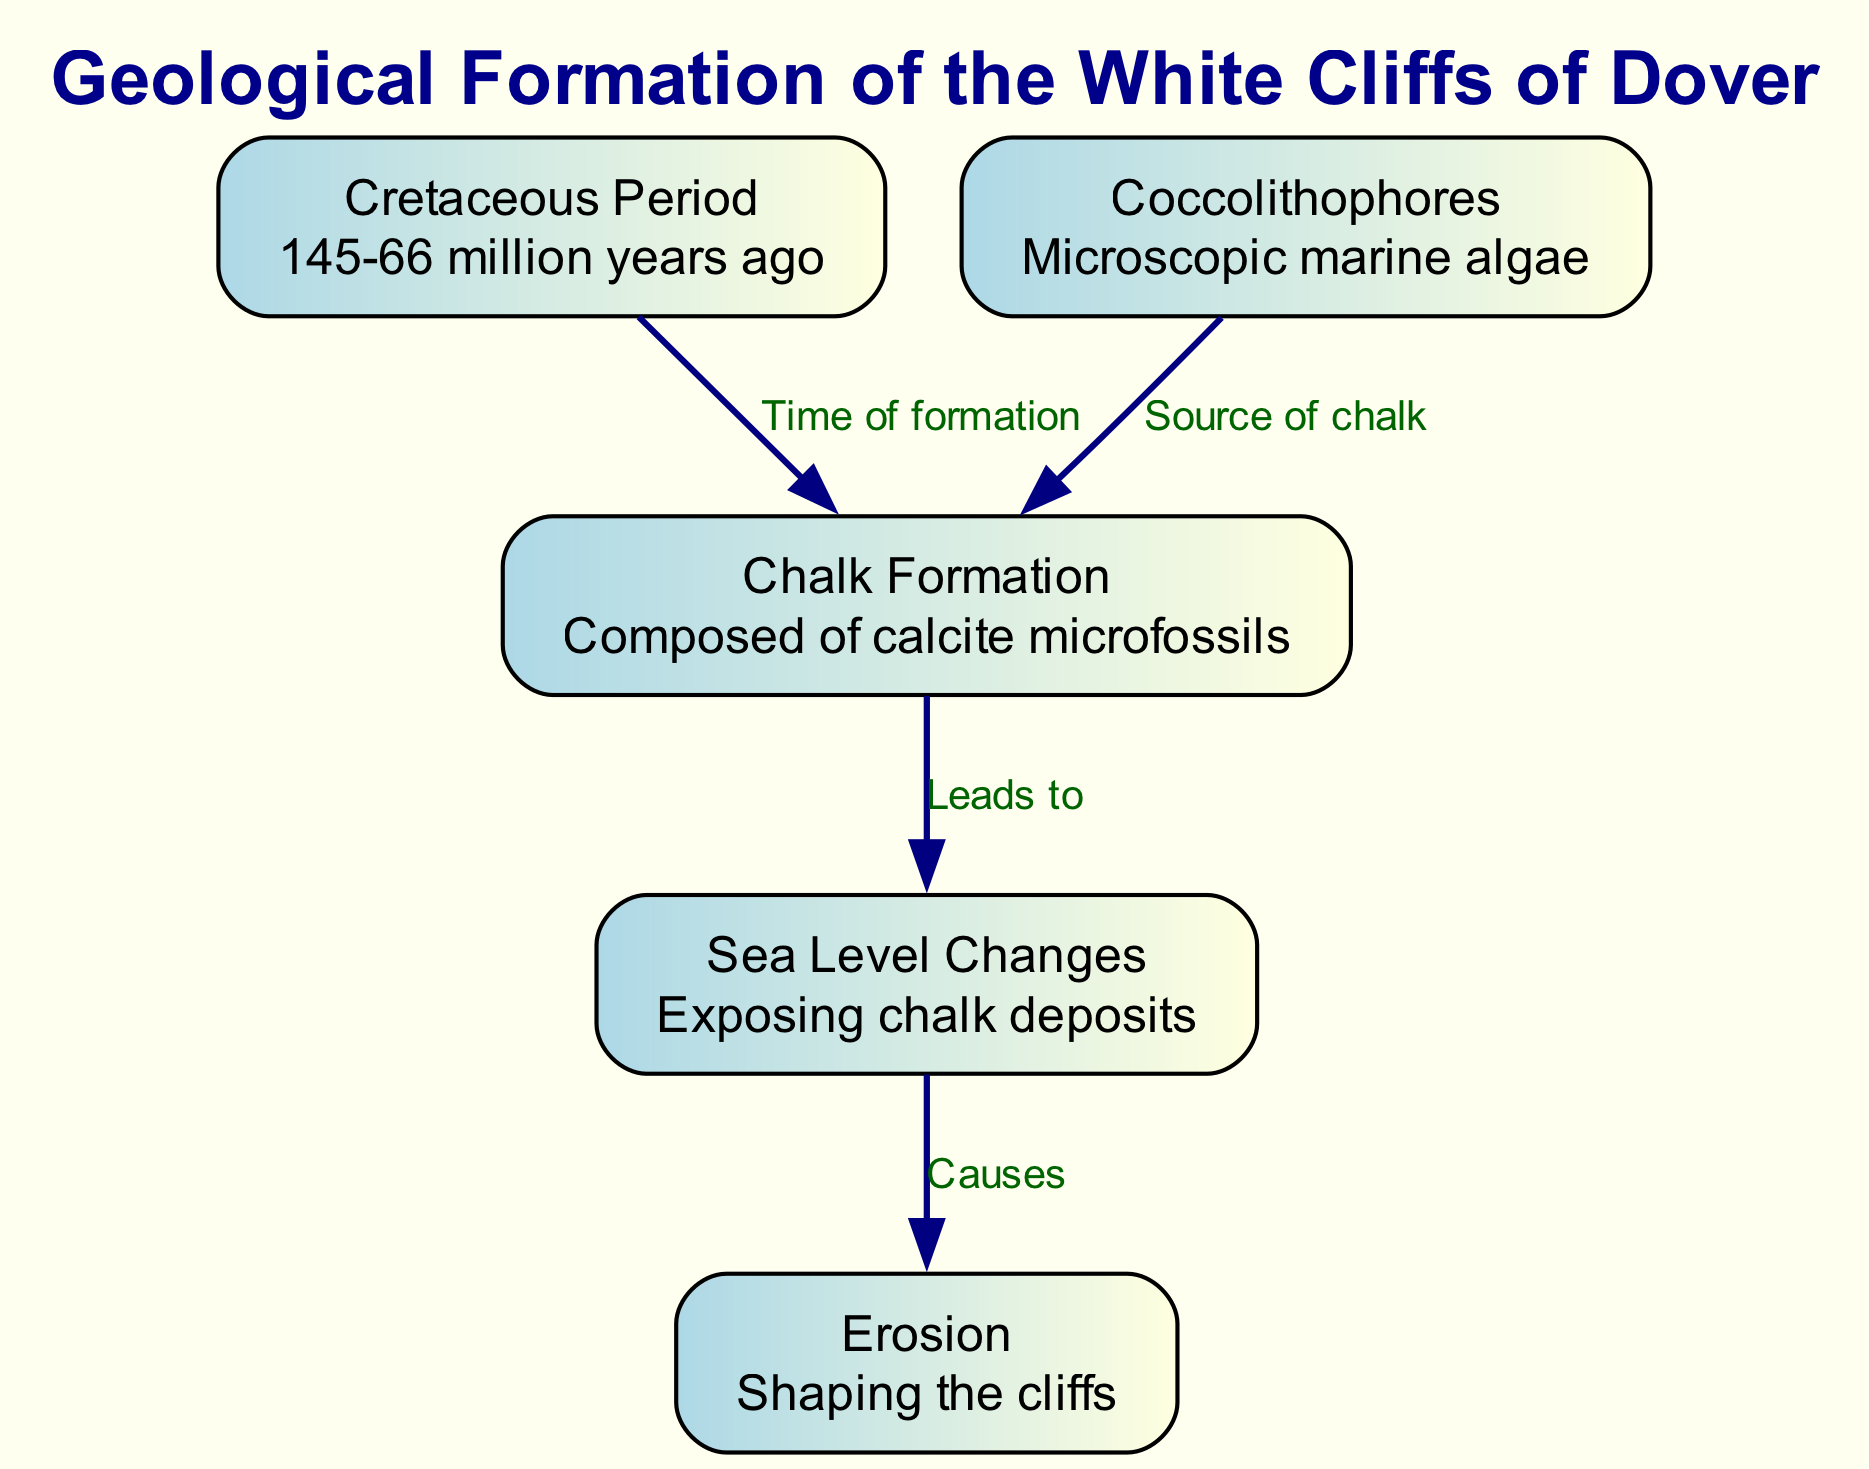What period did the geological formation of the White Cliffs of Dover occur? The diagram indicates that the Cretaceous Period lasted from 145 to 66 million years ago, which is when the White Cliffs began to form.
Answer: Cretaceous Period What is the composition of the Chalk Formation? According to the diagram, the Chalk Formation is composed of calcite microfossils, which provides insight into its geological makeup.
Answer: Calcite microfossils What key group of organisms contributed to the Chalk Formation? The diagram indicates that Coccolithophores, which are microscopic marine algae, are the source of the chalk.
Answer: Coccolithophores How many nodes are present in the diagram? By counting each distinctly labeled node in the diagram, we find there are five nodes representing different aspects of the geological formation.
Answer: 5 What causes the erosion that shapes the cliffs? The diagram shows that erosion is caused by sea level changes, which expose chalk deposits leading to the shaping of the cliffs over time.
Answer: Sea Level Changes What leads to the exposure of chalk deposits? The diagram indicates that the Chalk Formation leads to sea level changes, which expose the deposits. This connection explains the relationship between these elements.
Answer: Chalk Formation Which process is a result of sea level changes? The diagram clearly states that sea level changes cause erosion, illustrating the cause-and-effect relationship present in the geological processes.
Answer: Erosion What are the relationships between the Cretaceous Period and the Chalk Formation? The diagram specifies that the Cretaceous Period is the time of formation for the Chalk Formation, showing a chronological relationship between the two.
Answer: Time of formation What is the final outcome of the processes described in the diagram? The diagram concludes with erosion as the ultimate process that shapes the cliffs, showing how previous steps ultimately result in the current form of the White Cliffs.
Answer: Shaping the cliffs 